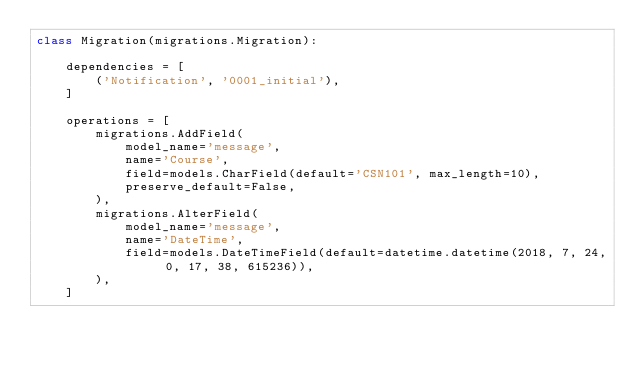<code> <loc_0><loc_0><loc_500><loc_500><_Python_>class Migration(migrations.Migration):

    dependencies = [
        ('Notification', '0001_initial'),
    ]

    operations = [
        migrations.AddField(
            model_name='message',
            name='Course',
            field=models.CharField(default='CSN101', max_length=10),
            preserve_default=False,
        ),
        migrations.AlterField(
            model_name='message',
            name='DateTime',
            field=models.DateTimeField(default=datetime.datetime(2018, 7, 24, 0, 17, 38, 615236)),
        ),
    ]
</code> 